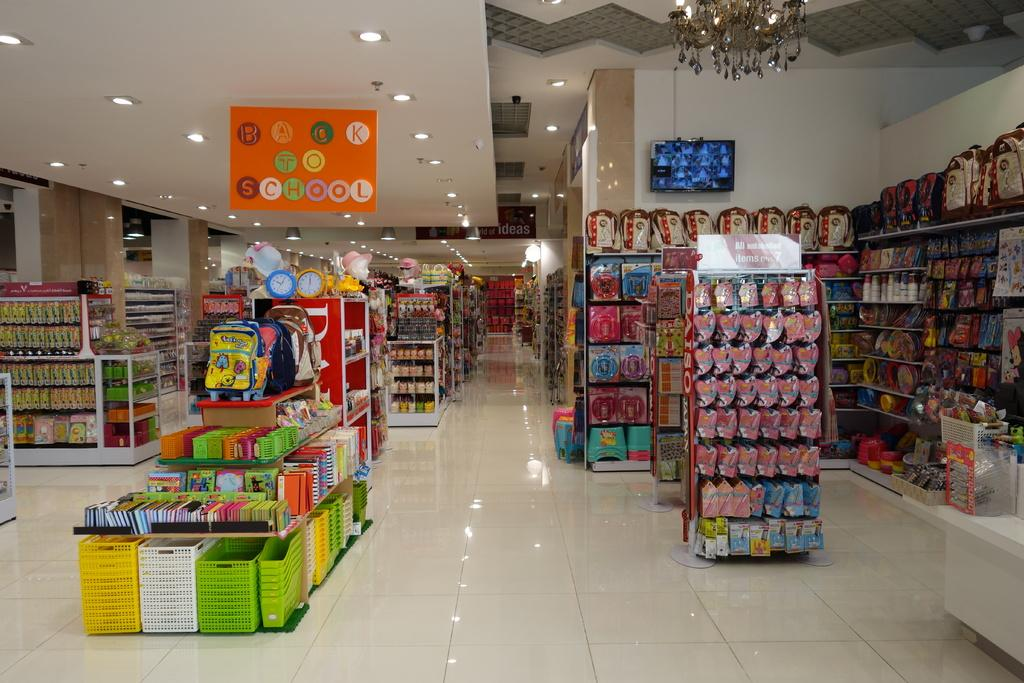<image>
Relay a brief, clear account of the picture shown. Back to school supplies that are displayed in a store. 